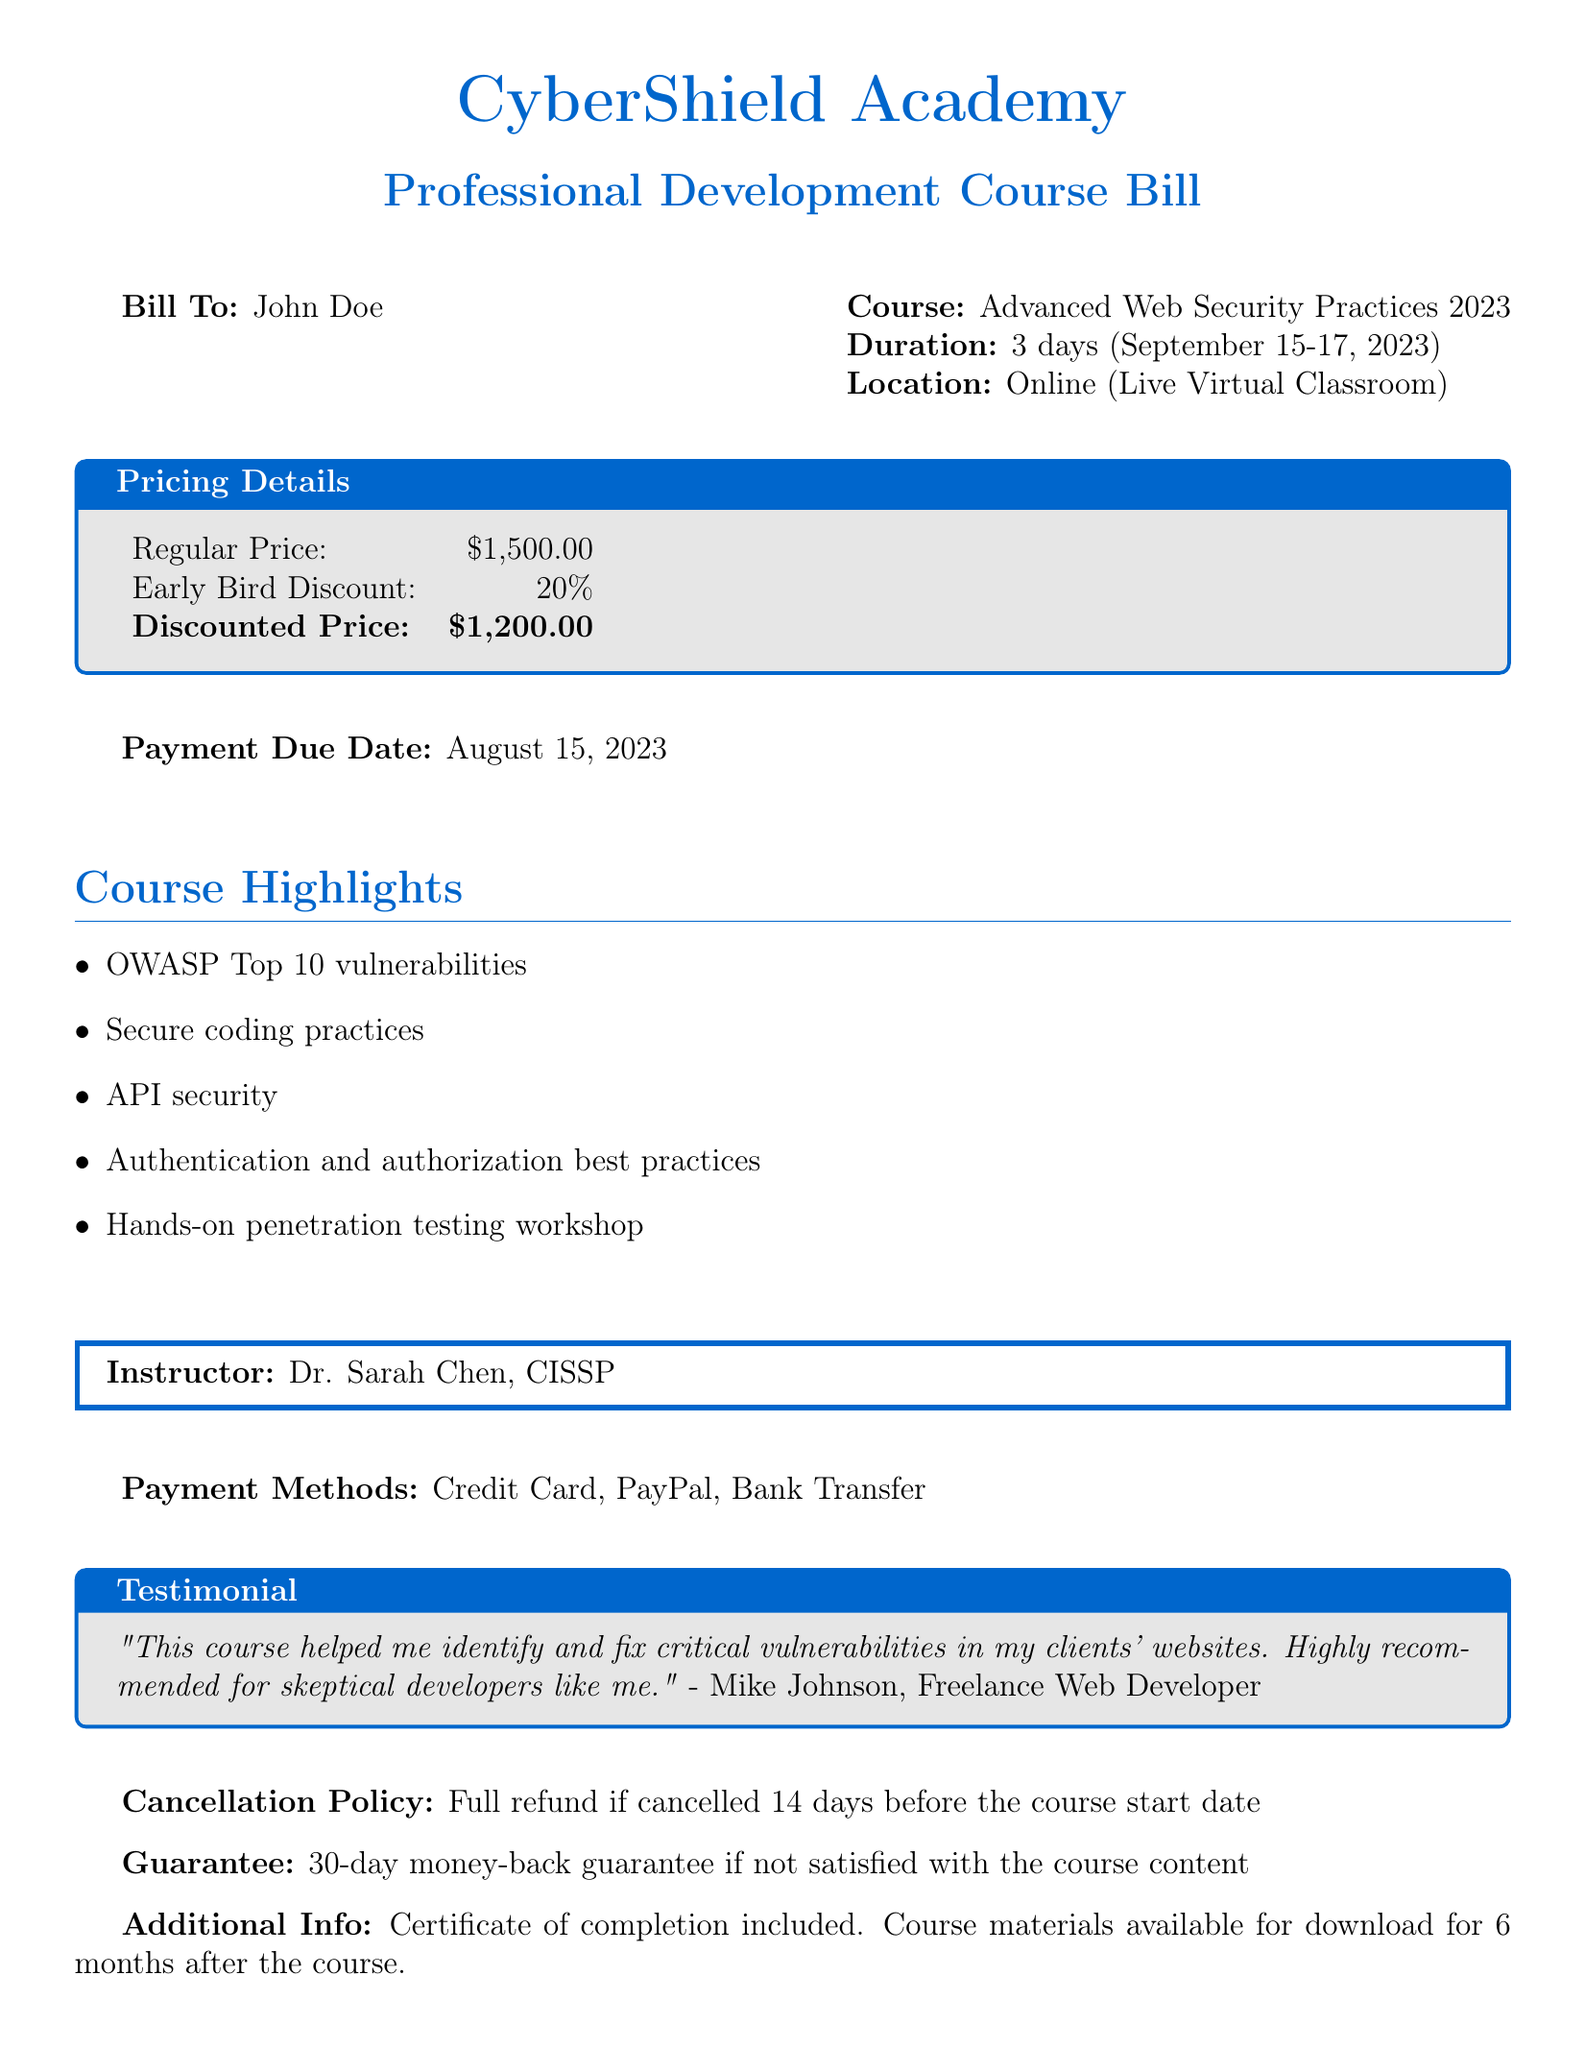What is the name of the academy? The name of the academy is provided at the top of the document.
Answer: CyberShield Academy What is the course duration? The duration of the course is stated in the course information section.
Answer: 3 days What is the early bird discount percentage? The document lists the early bird discount percentage in the pricing details box.
Answer: 20% What is the payment due date? The payment due date is clearly marked in the document.
Answer: August 15, 2023 Who is the instructor for the course? The document specifies the instructor's name inside a framed box.
Answer: Dr. Sarah Chen, CISSP What payment methods are accepted? The accepted payment methods are listed towards the end of the document.
Answer: Credit Card, PayPal, Bank Transfer What is the regular price of the course? The regular price is mentioned in the pricing details section.
Answer: $1,500.00 What is included with the course? The document states additional information on what is included.
Answer: Certificate of completion What is the cancellation policy? The cancellation policy is described clearly in a specific line of the document.
Answer: Full refund if cancelled 14 days before the course start date Is there a guarantee for the course? The guarantee for the course is mentioned in a specific section of the document.
Answer: 30-day money-back guarantee 